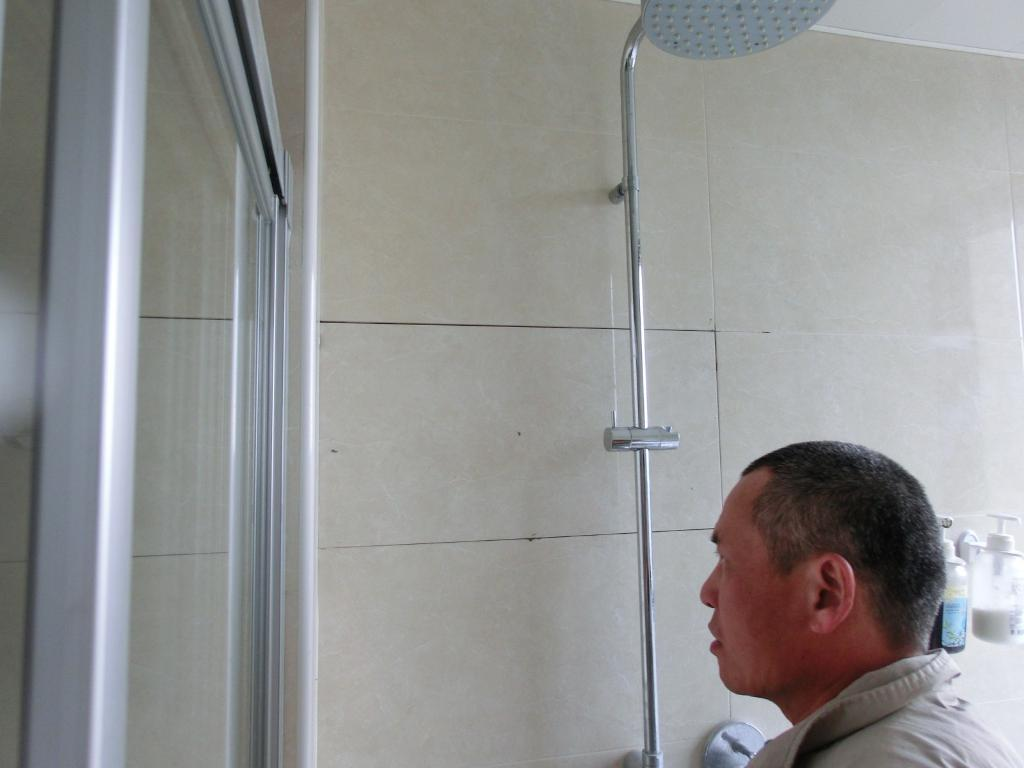What is the person in the image doing? The person is standing in the right corner of the image. What can be seen in front of the person? There is a shower in front of the person. What is located in the left corner of the image? There is a glass door in the left corner of the image. What type of whip is being used during the feast in the image? There is no feast or whip present in the image. How much lumber is visible in the image? There is no lumber visible in the image. 